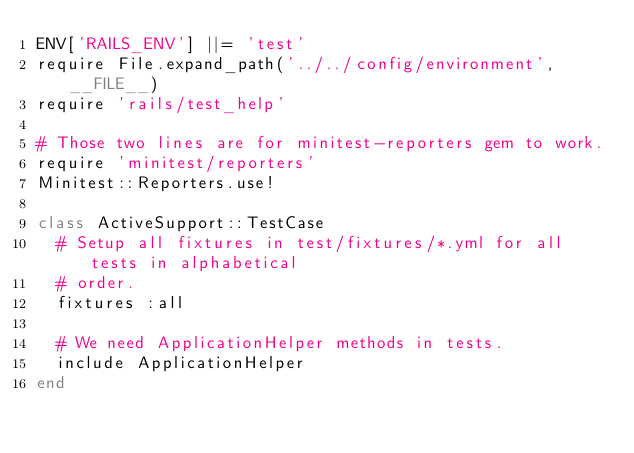Convert code to text. <code><loc_0><loc_0><loc_500><loc_500><_Ruby_>ENV['RAILS_ENV'] ||= 'test'
require File.expand_path('../../config/environment', __FILE__)
require 'rails/test_help'

# Those two lines are for minitest-reporters gem to work.
require 'minitest/reporters'
Minitest::Reporters.use!

class ActiveSupport::TestCase
  # Setup all fixtures in test/fixtures/*.yml for all tests in alphabetical
  # order.
  fixtures :all

  # We need ApplicationHelper methods in tests.
  include ApplicationHelper
end
</code> 